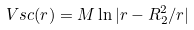Convert formula to latex. <formula><loc_0><loc_0><loc_500><loc_500>V { s c } ( r ) = M \ln | r - R ^ { 2 } _ { 2 } / r |</formula> 